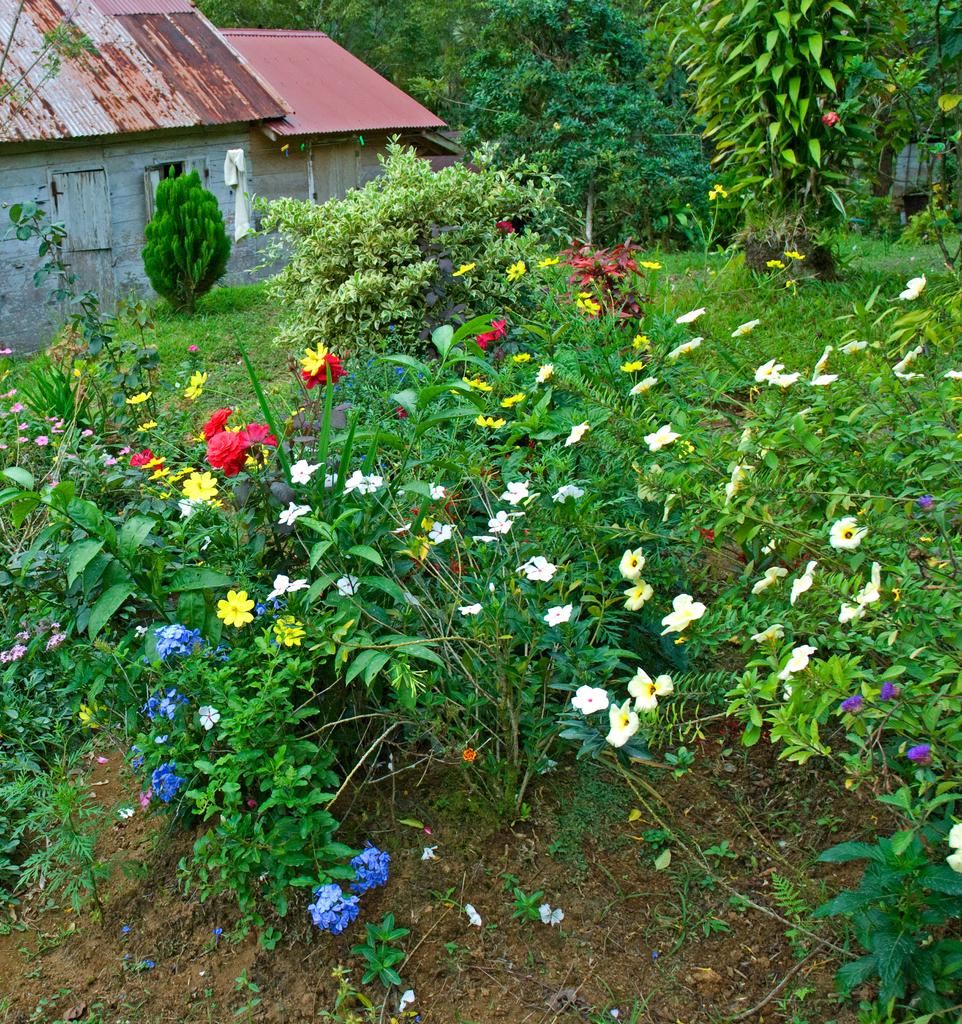What is in the center of the image? There are planets with different colored flowers in the center of the image. What can be seen in the background of the image? There are houses, trees, grass, and some unspecified objects in the background of the image. What type of pencil can be seen in the image? There is no pencil present in the image. Is there a lake visible in the image? There is no lake present in the image. 